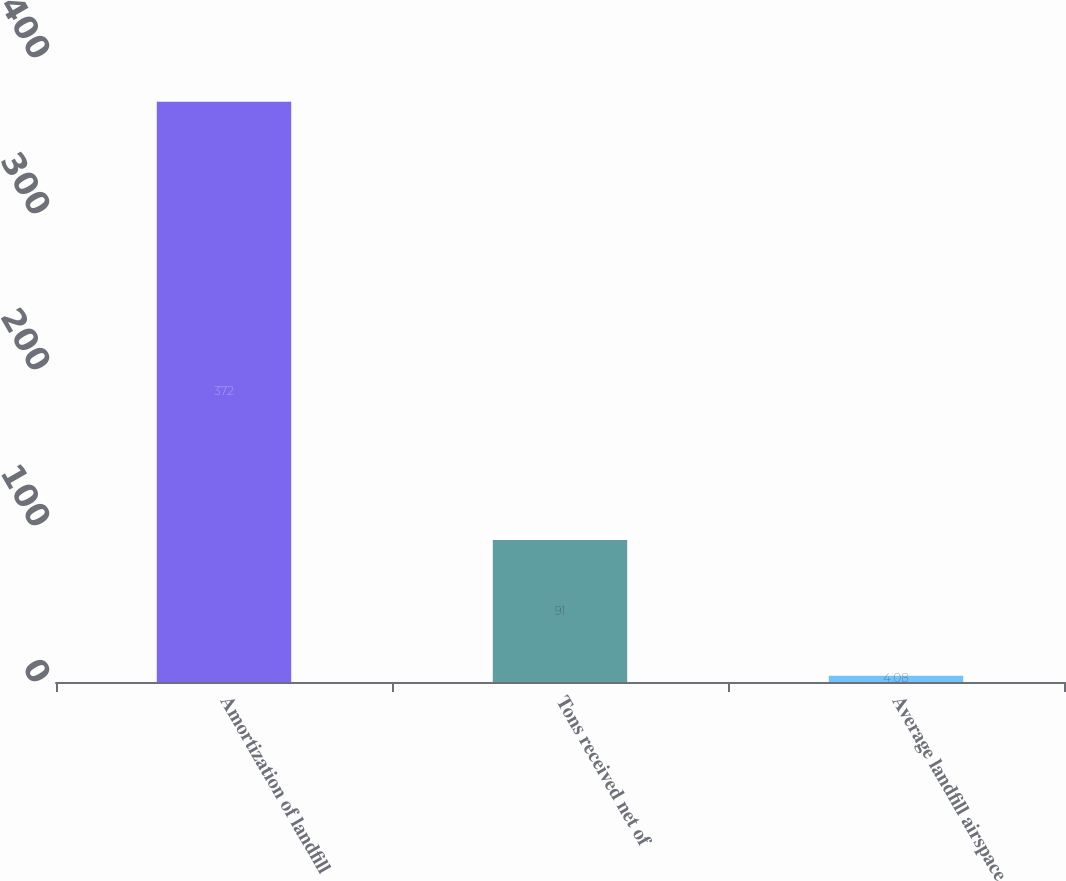<chart> <loc_0><loc_0><loc_500><loc_500><bar_chart><fcel>Amortization of landfill<fcel>Tons received net of<fcel>Average landfill airspace<nl><fcel>372<fcel>91<fcel>4.08<nl></chart> 